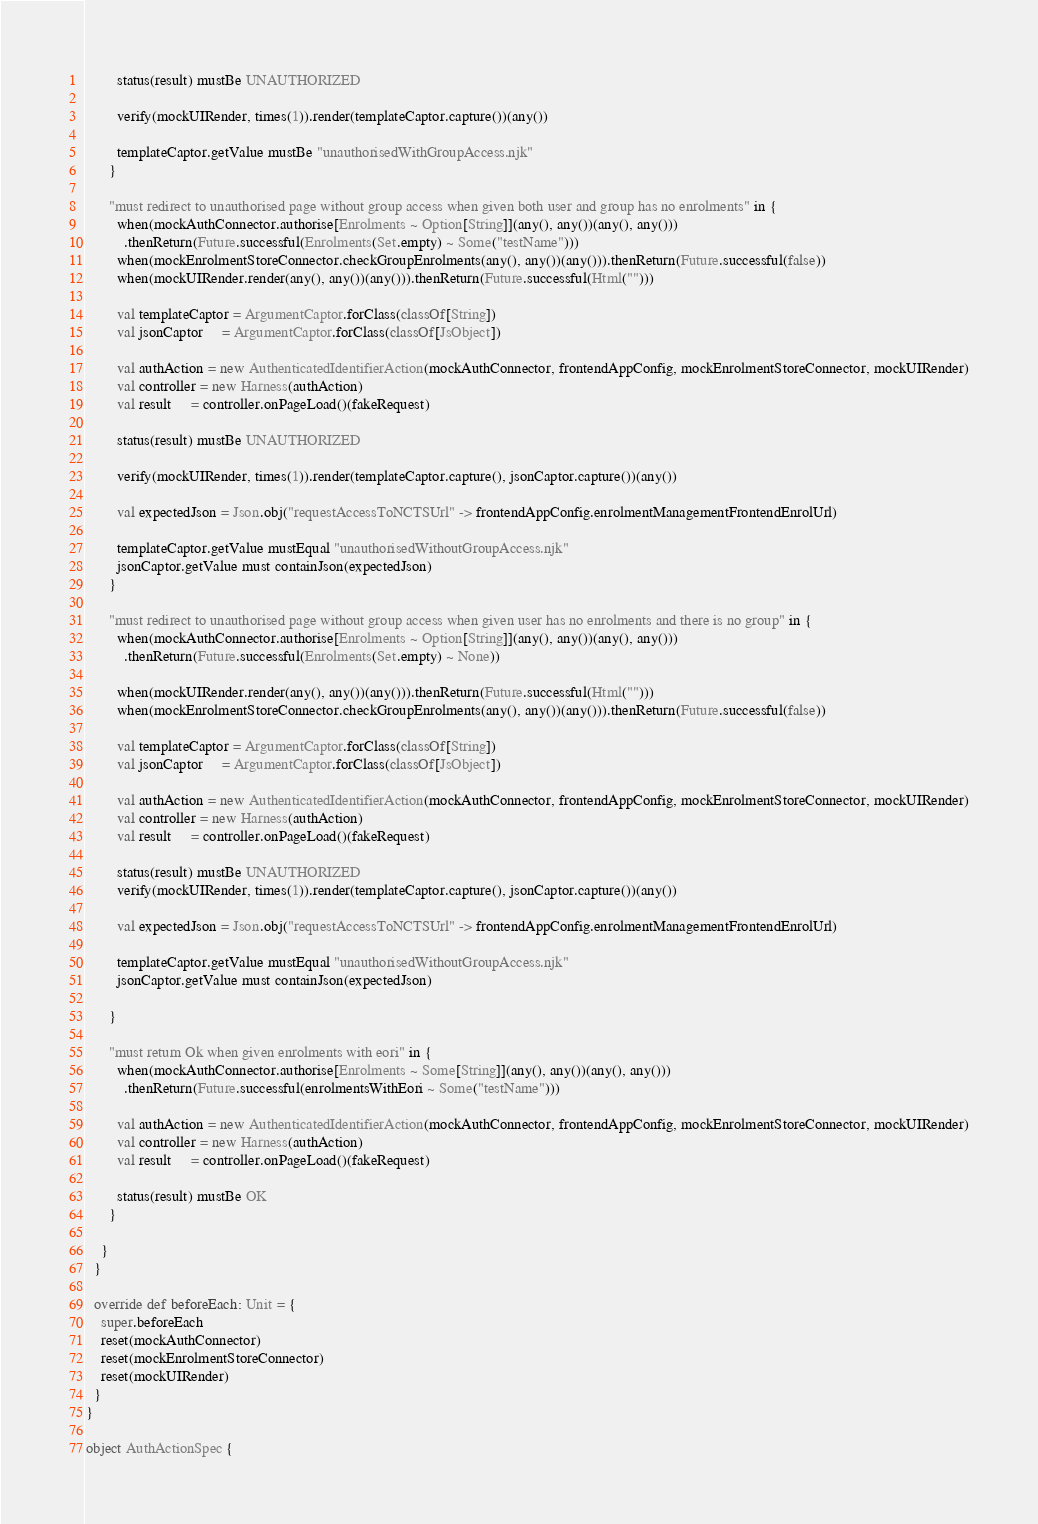<code> <loc_0><loc_0><loc_500><loc_500><_Scala_>
        status(result) mustBe UNAUTHORIZED

        verify(mockUIRender, times(1)).render(templateCaptor.capture())(any())

        templateCaptor.getValue mustBe "unauthorisedWithGroupAccess.njk"
      }

      "must redirect to unauthorised page without group access when given both user and group has no enrolments" in {
        when(mockAuthConnector.authorise[Enrolments ~ Option[String]](any(), any())(any(), any()))
          .thenReturn(Future.successful(Enrolments(Set.empty) ~ Some("testName")))
        when(mockEnrolmentStoreConnector.checkGroupEnrolments(any(), any())(any())).thenReturn(Future.successful(false))
        when(mockUIRender.render(any(), any())(any())).thenReturn(Future.successful(Html("")))

        val templateCaptor = ArgumentCaptor.forClass(classOf[String])
        val jsonCaptor     = ArgumentCaptor.forClass(classOf[JsObject])

        val authAction = new AuthenticatedIdentifierAction(mockAuthConnector, frontendAppConfig, mockEnrolmentStoreConnector, mockUIRender)
        val controller = new Harness(authAction)
        val result     = controller.onPageLoad()(fakeRequest)

        status(result) mustBe UNAUTHORIZED

        verify(mockUIRender, times(1)).render(templateCaptor.capture(), jsonCaptor.capture())(any())

        val expectedJson = Json.obj("requestAccessToNCTSUrl" -> frontendAppConfig.enrolmentManagementFrontendEnrolUrl)

        templateCaptor.getValue mustEqual "unauthorisedWithoutGroupAccess.njk"
        jsonCaptor.getValue must containJson(expectedJson)
      }

      "must redirect to unauthorised page without group access when given user has no enrolments and there is no group" in {
        when(mockAuthConnector.authorise[Enrolments ~ Option[String]](any(), any())(any(), any()))
          .thenReturn(Future.successful(Enrolments(Set.empty) ~ None))

        when(mockUIRender.render(any(), any())(any())).thenReturn(Future.successful(Html("")))
        when(mockEnrolmentStoreConnector.checkGroupEnrolments(any(), any())(any())).thenReturn(Future.successful(false))

        val templateCaptor = ArgumentCaptor.forClass(classOf[String])
        val jsonCaptor     = ArgumentCaptor.forClass(classOf[JsObject])

        val authAction = new AuthenticatedIdentifierAction(mockAuthConnector, frontendAppConfig, mockEnrolmentStoreConnector, mockUIRender)
        val controller = new Harness(authAction)
        val result     = controller.onPageLoad()(fakeRequest)

        status(result) mustBe UNAUTHORIZED
        verify(mockUIRender, times(1)).render(templateCaptor.capture(), jsonCaptor.capture())(any())

        val expectedJson = Json.obj("requestAccessToNCTSUrl" -> frontendAppConfig.enrolmentManagementFrontendEnrolUrl)

        templateCaptor.getValue mustEqual "unauthorisedWithoutGroupAccess.njk"
        jsonCaptor.getValue must containJson(expectedJson)

      }

      "must return Ok when given enrolments with eori" in {
        when(mockAuthConnector.authorise[Enrolments ~ Some[String]](any(), any())(any(), any()))
          .thenReturn(Future.successful(enrolmentsWithEori ~ Some("testName")))

        val authAction = new AuthenticatedIdentifierAction(mockAuthConnector, frontendAppConfig, mockEnrolmentStoreConnector, mockUIRender)
        val controller = new Harness(authAction)
        val result     = controller.onPageLoad()(fakeRequest)

        status(result) mustBe OK
      }

    }
  }

  override def beforeEach: Unit = {
    super.beforeEach
    reset(mockAuthConnector)
    reset(mockEnrolmentStoreConnector)
    reset(mockUIRender)
  }
}

object AuthActionSpec {
</code> 